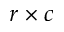Convert formula to latex. <formula><loc_0><loc_0><loc_500><loc_500>r \times c</formula> 